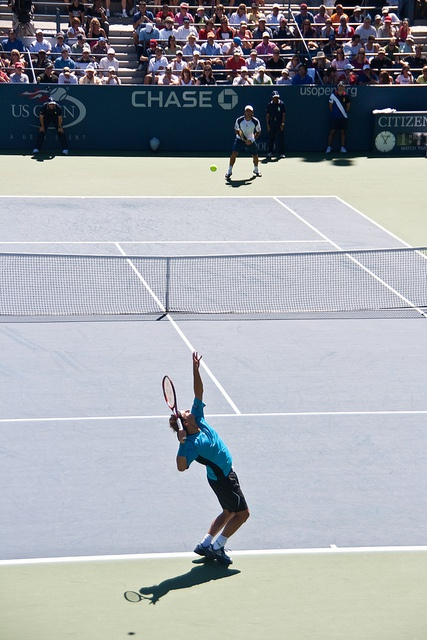Describe the objects in this image and their specific colors. I can see people in navy, black, blue, and darkblue tones, people in navy, black, gray, and ivory tones, people in navy, black, gray, lightgray, and maroon tones, people in navy, black, and gray tones, and people in navy, white, maroon, and black tones in this image. 